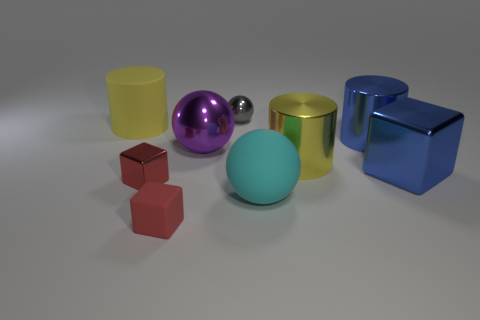What colors are present in the image? The objects in the image showcase a variety of colors including yellow, purple, silver, gold, blue, and red, with a large cyan sphere also present. 